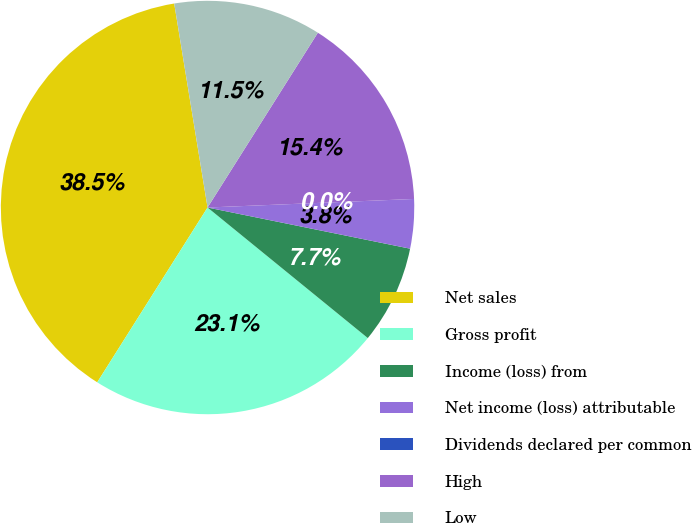Convert chart to OTSL. <chart><loc_0><loc_0><loc_500><loc_500><pie_chart><fcel>Net sales<fcel>Gross profit<fcel>Income (loss) from<fcel>Net income (loss) attributable<fcel>Dividends declared per common<fcel>High<fcel>Low<nl><fcel>38.46%<fcel>23.08%<fcel>7.69%<fcel>3.85%<fcel>0.0%<fcel>15.38%<fcel>11.54%<nl></chart> 